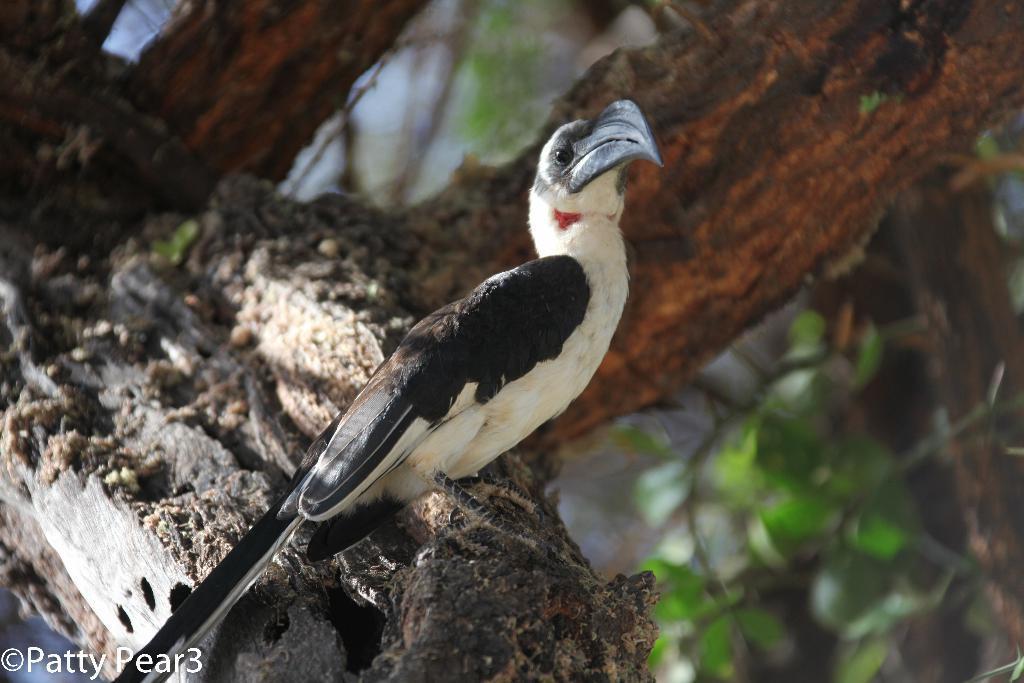How would you summarize this image in a sentence or two? In this picture we can see a bird which is in the color combination of white and black. And these are the leaves. 